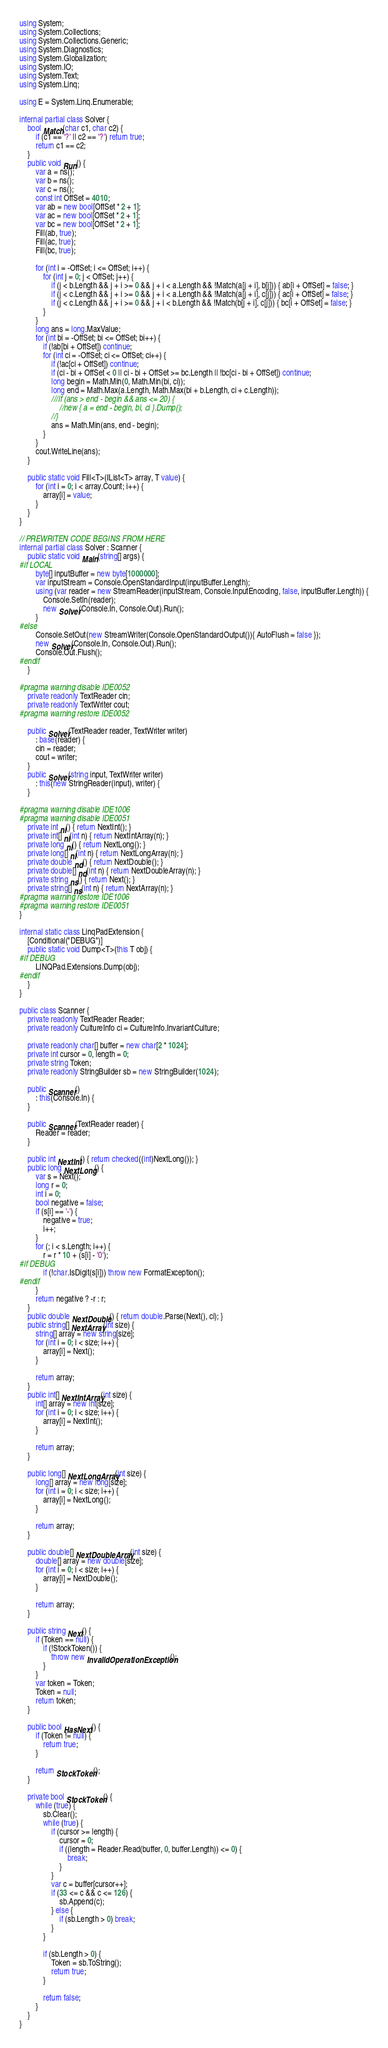<code> <loc_0><loc_0><loc_500><loc_500><_C#_>using System;
using System.Collections;
using System.Collections.Generic;
using System.Diagnostics;
using System.Globalization;
using System.IO;
using System.Text;
using System.Linq;

using E = System.Linq.Enumerable;

internal partial class Solver {
    bool Match(char c1, char c2) {
        if (c1 == '?' || c2 == '?') return true;
        return c1 == c2;
    }
    public void Run() {
        var a = ns();
        var b = ns();
        var c = ns();
        const int OffSet = 4010;
        var ab = new bool[OffSet * 2 + 1];
        var ac = new bool[OffSet * 2 + 1];
        var bc = new bool[OffSet * 2 + 1];
        Fill(ab, true);
        Fill(ac, true);
        Fill(bc, true);

        for (int i = -OffSet; i <= OffSet; i++) {
            for (int j = 0; j < OffSet; j++) {
                if (j < b.Length && j + i >= 0 && j + i < a.Length && !Match(a[j + i], b[j])) { ab[i + OffSet] = false; }
                if (j < c.Length && j + i >= 0 && j + i < a.Length && !Match(a[j + i], c[j])) { ac[i + OffSet] = false; }
                if (j < c.Length && j + i >= 0 && j + i < b.Length && !Match(b[j + i], c[j])) { bc[i + OffSet] = false; }
            }
        }
        long ans = long.MaxValue;
        for (int bi = -OffSet; bi <= OffSet; bi++) {
            if (!ab[bi + OffSet]) continue;
            for (int ci = -OffSet; ci <= OffSet; ci++) {
                if (!ac[ci + OffSet]) continue;
                if (ci - bi + OffSet < 0 || ci - bi + OffSet >= bc.Length || !bc[ci - bi + OffSet]) continue;
                long begin = Math.Min(0, Math.Min(bi, ci));
                long end = Math.Max(a.Length, Math.Max(bi + b.Length, ci + c.Length));
                ///if (ans > end - begin && ans <= 20) {
                    //new { a = end - begin, bi, ci }.Dump();
                //}
                ans = Math.Min(ans, end - begin);
            }
        }
        cout.WriteLine(ans);
    }

    public static void Fill<T>(IList<T> array, T value) {
        for (int i = 0; i < array.Count; i++) {
            array[i] = value;
        }
    }
}

// PREWRITEN CODE BEGINS FROM HERE
internal partial class Solver : Scanner {
    public static void Main(string[] args) {
#if LOCAL
        byte[] inputBuffer = new byte[1000000];
        var inputStream = Console.OpenStandardInput(inputBuffer.Length);
        using (var reader = new StreamReader(inputStream, Console.InputEncoding, false, inputBuffer.Length)) {
            Console.SetIn(reader);
            new Solver(Console.In, Console.Out).Run();
        }
#else
        Console.SetOut(new StreamWriter(Console.OpenStandardOutput()){ AutoFlush = false });
        new Solver(Console.In, Console.Out).Run();
        Console.Out.Flush();
#endif
    }

#pragma warning disable IDE0052
    private readonly TextReader cin;
    private readonly TextWriter cout;
#pragma warning restore IDE0052

    public Solver(TextReader reader, TextWriter writer)
        : base(reader) {
        cin = reader;
        cout = writer;
    }
    public Solver(string input, TextWriter writer)
        : this(new StringReader(input), writer) {
    }

#pragma warning disable IDE1006
#pragma warning disable IDE0051
    private int ni() { return NextInt(); }
    private int[] ni(int n) { return NextIntArray(n); }
    private long nl() { return NextLong(); }
    private long[] nl(int n) { return NextLongArray(n); }
    private double nd() { return NextDouble(); }
    private double[] nd(int n) { return NextDoubleArray(n); }
    private string ns() { return Next(); }
    private string[] ns(int n) { return NextArray(n); }
#pragma warning restore IDE1006
#pragma warning restore IDE0051
}

internal static class LinqPadExtension {
    [Conditional("DEBUG")]
    public static void Dump<T>(this T obj) {
#if DEBUG
        LINQPad.Extensions.Dump(obj);
#endif
    }
}

public class Scanner {
    private readonly TextReader Reader;
    private readonly CultureInfo ci = CultureInfo.InvariantCulture;

    private readonly char[] buffer = new char[2 * 1024];
    private int cursor = 0, length = 0;
    private string Token;
    private readonly StringBuilder sb = new StringBuilder(1024);

    public Scanner()
        : this(Console.In) {
    }

    public Scanner(TextReader reader) {
        Reader = reader;
    }

    public int NextInt() { return checked((int)NextLong()); }
    public long NextLong() {
        var s = Next();
        long r = 0;
        int i = 0;
        bool negative = false;
        if (s[i] == '-') {
            negative = true;
            i++;
        }
        for (; i < s.Length; i++) {
            r = r * 10 + (s[i] - '0');
#if DEBUG
            if (!char.IsDigit(s[i])) throw new FormatException();
#endif
        }
        return negative ? -r : r;
    }
    public double NextDouble() { return double.Parse(Next(), ci); }
    public string[] NextArray(int size) {
        string[] array = new string[size];
        for (int i = 0; i < size; i++) {
            array[i] = Next();
        }

        return array;
    }
    public int[] NextIntArray(int size) {
        int[] array = new int[size];
        for (int i = 0; i < size; i++) {
            array[i] = NextInt();
        }

        return array;
    }

    public long[] NextLongArray(int size) {
        long[] array = new long[size];
        for (int i = 0; i < size; i++) {
            array[i] = NextLong();
        }

        return array;
    }

    public double[] NextDoubleArray(int size) {
        double[] array = new double[size];
        for (int i = 0; i < size; i++) {
            array[i] = NextDouble();
        }

        return array;
    }

    public string Next() {
        if (Token == null) {
            if (!StockToken()) {
                throw new InvalidOperationException();
            }
        }
        var token = Token;
        Token = null;
        return token;
    }

    public bool HasNext() {
        if (Token != null) {
            return true;
        }

        return StockToken();
    }

    private bool StockToken() {
        while (true) {
            sb.Clear();
            while (true) {
                if (cursor >= length) {
                    cursor = 0;
                    if ((length = Reader.Read(buffer, 0, buffer.Length)) <= 0) {
                        break;
                    }
                }
                var c = buffer[cursor++];
                if (33 <= c && c <= 126) {
                    sb.Append(c);
                } else {
                    if (sb.Length > 0) break;
                }
            }

            if (sb.Length > 0) {
                Token = sb.ToString();
                return true;
            }

            return false;
        }
    }
}</code> 